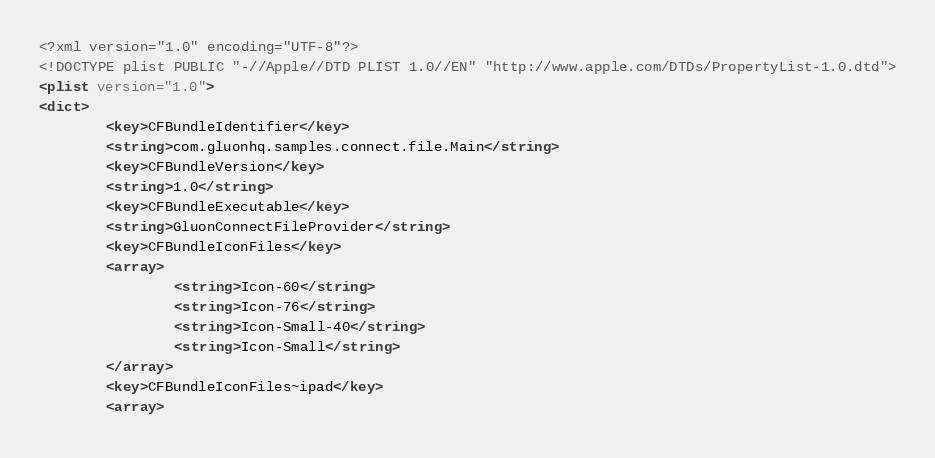<code> <loc_0><loc_0><loc_500><loc_500><_XML_><?xml version="1.0" encoding="UTF-8"?>
<!DOCTYPE plist PUBLIC "-//Apple//DTD PLIST 1.0//EN" "http://www.apple.com/DTDs/PropertyList-1.0.dtd">
<plist version="1.0">
<dict>
        <key>CFBundleIdentifier</key>
        <string>com.gluonhq.samples.connect.file.Main</string>
        <key>CFBundleVersion</key>
        <string>1.0</string>
        <key>CFBundleExecutable</key>
        <string>GluonConnectFileProvider</string>
        <key>CFBundleIconFiles</key>
        <array>
                <string>Icon-60</string>
                <string>Icon-76</string>
                <string>Icon-Small-40</string>
                <string>Icon-Small</string>
        </array>
        <key>CFBundleIconFiles~ipad</key>
        <array></code> 